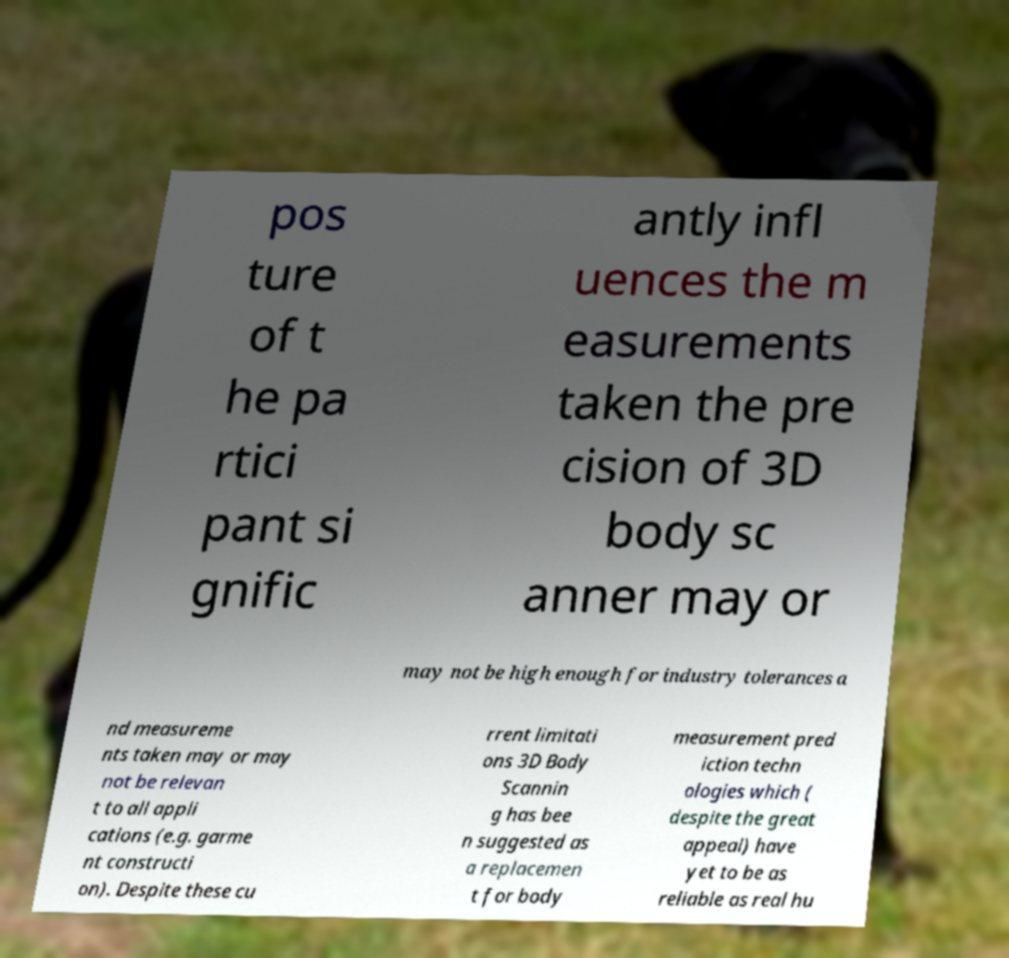For documentation purposes, I need the text within this image transcribed. Could you provide that? pos ture of t he pa rtici pant si gnific antly infl uences the m easurements taken the pre cision of 3D body sc anner may or may not be high enough for industry tolerances a nd measureme nts taken may or may not be relevan t to all appli cations (e.g. garme nt constructi on). Despite these cu rrent limitati ons 3D Body Scannin g has bee n suggested as a replacemen t for body measurement pred iction techn ologies which ( despite the great appeal) have yet to be as reliable as real hu 